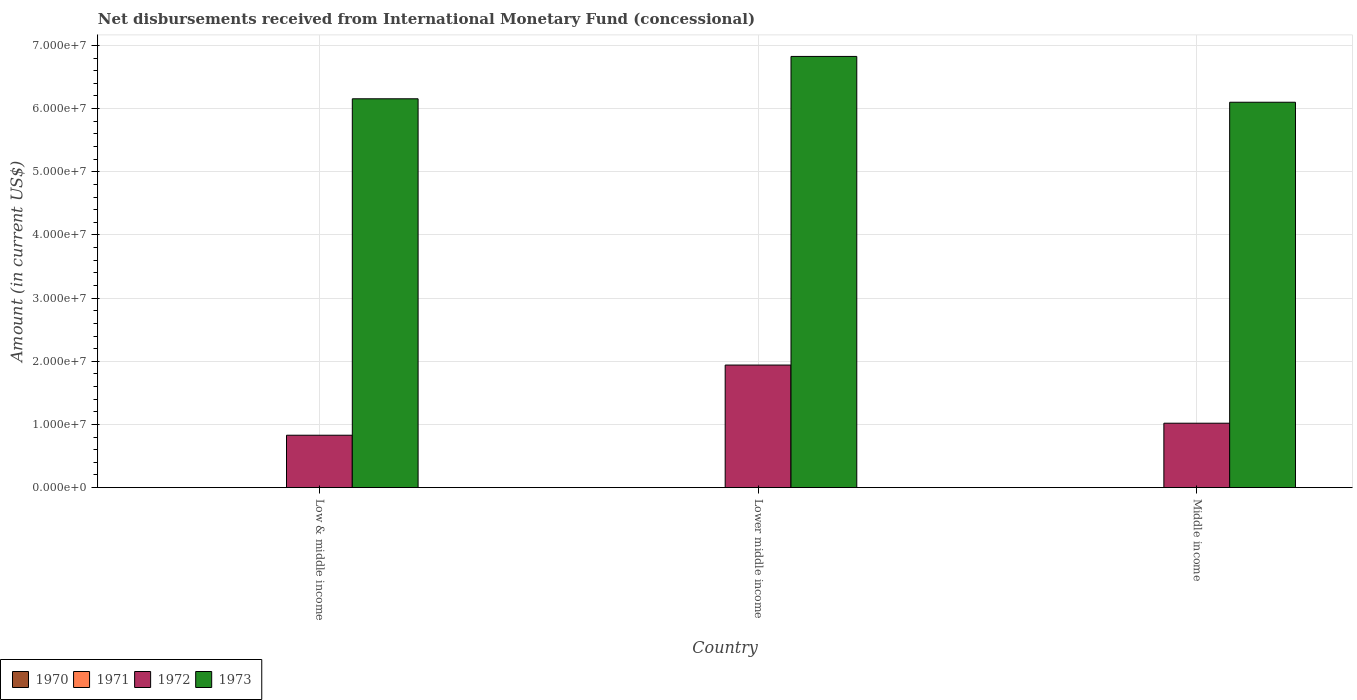How many groups of bars are there?
Provide a short and direct response. 3. Are the number of bars per tick equal to the number of legend labels?
Provide a succinct answer. No. How many bars are there on the 3rd tick from the left?
Your answer should be very brief. 2. What is the label of the 1st group of bars from the left?
Provide a short and direct response. Low & middle income. In how many cases, is the number of bars for a given country not equal to the number of legend labels?
Your answer should be compact. 3. What is the amount of disbursements received from International Monetary Fund in 1971 in Low & middle income?
Ensure brevity in your answer.  0. Across all countries, what is the maximum amount of disbursements received from International Monetary Fund in 1973?
Provide a short and direct response. 6.83e+07. In which country was the amount of disbursements received from International Monetary Fund in 1972 maximum?
Keep it short and to the point. Lower middle income. What is the difference between the amount of disbursements received from International Monetary Fund in 1973 in Low & middle income and that in Lower middle income?
Provide a short and direct response. -6.70e+06. What is the difference between the amount of disbursements received from International Monetary Fund in 1972 in Low & middle income and the amount of disbursements received from International Monetary Fund in 1970 in Lower middle income?
Your response must be concise. 8.30e+06. What is the average amount of disbursements received from International Monetary Fund in 1973 per country?
Give a very brief answer. 6.36e+07. What is the difference between the amount of disbursements received from International Monetary Fund of/in 1972 and amount of disbursements received from International Monetary Fund of/in 1973 in Middle income?
Your response must be concise. -5.08e+07. What is the ratio of the amount of disbursements received from International Monetary Fund in 1972 in Low & middle income to that in Lower middle income?
Ensure brevity in your answer.  0.43. What is the difference between the highest and the second highest amount of disbursements received from International Monetary Fund in 1973?
Your answer should be compact. -7.25e+06. What is the difference between the highest and the lowest amount of disbursements received from International Monetary Fund in 1973?
Provide a succinct answer. 7.25e+06. In how many countries, is the amount of disbursements received from International Monetary Fund in 1973 greater than the average amount of disbursements received from International Monetary Fund in 1973 taken over all countries?
Ensure brevity in your answer.  1. Is the sum of the amount of disbursements received from International Monetary Fund in 1972 in Low & middle income and Middle income greater than the maximum amount of disbursements received from International Monetary Fund in 1970 across all countries?
Provide a succinct answer. Yes. Is it the case that in every country, the sum of the amount of disbursements received from International Monetary Fund in 1970 and amount of disbursements received from International Monetary Fund in 1973 is greater than the sum of amount of disbursements received from International Monetary Fund in 1971 and amount of disbursements received from International Monetary Fund in 1972?
Provide a short and direct response. No. Is it the case that in every country, the sum of the amount of disbursements received from International Monetary Fund in 1971 and amount of disbursements received from International Monetary Fund in 1973 is greater than the amount of disbursements received from International Monetary Fund in 1972?
Your answer should be very brief. Yes. Are all the bars in the graph horizontal?
Provide a succinct answer. No. How many countries are there in the graph?
Your response must be concise. 3. Are the values on the major ticks of Y-axis written in scientific E-notation?
Provide a succinct answer. Yes. Where does the legend appear in the graph?
Provide a succinct answer. Bottom left. How many legend labels are there?
Keep it short and to the point. 4. What is the title of the graph?
Your response must be concise. Net disbursements received from International Monetary Fund (concessional). What is the Amount (in current US$) in 1972 in Low & middle income?
Offer a very short reply. 8.30e+06. What is the Amount (in current US$) in 1973 in Low & middle income?
Keep it short and to the point. 6.16e+07. What is the Amount (in current US$) in 1970 in Lower middle income?
Ensure brevity in your answer.  0. What is the Amount (in current US$) of 1971 in Lower middle income?
Make the answer very short. 0. What is the Amount (in current US$) in 1972 in Lower middle income?
Give a very brief answer. 1.94e+07. What is the Amount (in current US$) in 1973 in Lower middle income?
Keep it short and to the point. 6.83e+07. What is the Amount (in current US$) of 1970 in Middle income?
Provide a succinct answer. 0. What is the Amount (in current US$) in 1971 in Middle income?
Your response must be concise. 0. What is the Amount (in current US$) in 1972 in Middle income?
Make the answer very short. 1.02e+07. What is the Amount (in current US$) of 1973 in Middle income?
Offer a very short reply. 6.10e+07. Across all countries, what is the maximum Amount (in current US$) of 1972?
Keep it short and to the point. 1.94e+07. Across all countries, what is the maximum Amount (in current US$) in 1973?
Give a very brief answer. 6.83e+07. Across all countries, what is the minimum Amount (in current US$) of 1972?
Your answer should be very brief. 8.30e+06. Across all countries, what is the minimum Amount (in current US$) of 1973?
Give a very brief answer. 6.10e+07. What is the total Amount (in current US$) of 1971 in the graph?
Give a very brief answer. 0. What is the total Amount (in current US$) of 1972 in the graph?
Your response must be concise. 3.79e+07. What is the total Amount (in current US$) of 1973 in the graph?
Keep it short and to the point. 1.91e+08. What is the difference between the Amount (in current US$) in 1972 in Low & middle income and that in Lower middle income?
Your answer should be compact. -1.11e+07. What is the difference between the Amount (in current US$) in 1973 in Low & middle income and that in Lower middle income?
Your answer should be very brief. -6.70e+06. What is the difference between the Amount (in current US$) of 1972 in Low & middle income and that in Middle income?
Your response must be concise. -1.90e+06. What is the difference between the Amount (in current US$) in 1973 in Low & middle income and that in Middle income?
Offer a terse response. 5.46e+05. What is the difference between the Amount (in current US$) in 1972 in Lower middle income and that in Middle income?
Your answer should be very brief. 9.21e+06. What is the difference between the Amount (in current US$) in 1973 in Lower middle income and that in Middle income?
Your answer should be compact. 7.25e+06. What is the difference between the Amount (in current US$) of 1972 in Low & middle income and the Amount (in current US$) of 1973 in Lower middle income?
Provide a short and direct response. -6.00e+07. What is the difference between the Amount (in current US$) of 1972 in Low & middle income and the Amount (in current US$) of 1973 in Middle income?
Keep it short and to the point. -5.27e+07. What is the difference between the Amount (in current US$) in 1972 in Lower middle income and the Amount (in current US$) in 1973 in Middle income?
Your answer should be compact. -4.16e+07. What is the average Amount (in current US$) in 1971 per country?
Ensure brevity in your answer.  0. What is the average Amount (in current US$) in 1972 per country?
Your answer should be very brief. 1.26e+07. What is the average Amount (in current US$) of 1973 per country?
Your response must be concise. 6.36e+07. What is the difference between the Amount (in current US$) in 1972 and Amount (in current US$) in 1973 in Low & middle income?
Provide a succinct answer. -5.33e+07. What is the difference between the Amount (in current US$) in 1972 and Amount (in current US$) in 1973 in Lower middle income?
Ensure brevity in your answer.  -4.89e+07. What is the difference between the Amount (in current US$) of 1972 and Amount (in current US$) of 1973 in Middle income?
Offer a terse response. -5.08e+07. What is the ratio of the Amount (in current US$) in 1972 in Low & middle income to that in Lower middle income?
Make the answer very short. 0.43. What is the ratio of the Amount (in current US$) in 1973 in Low & middle income to that in Lower middle income?
Keep it short and to the point. 0.9. What is the ratio of the Amount (in current US$) of 1972 in Low & middle income to that in Middle income?
Offer a terse response. 0.81. What is the ratio of the Amount (in current US$) in 1972 in Lower middle income to that in Middle income?
Your answer should be compact. 1.9. What is the ratio of the Amount (in current US$) of 1973 in Lower middle income to that in Middle income?
Offer a very short reply. 1.12. What is the difference between the highest and the second highest Amount (in current US$) of 1972?
Keep it short and to the point. 9.21e+06. What is the difference between the highest and the second highest Amount (in current US$) of 1973?
Make the answer very short. 6.70e+06. What is the difference between the highest and the lowest Amount (in current US$) of 1972?
Give a very brief answer. 1.11e+07. What is the difference between the highest and the lowest Amount (in current US$) in 1973?
Make the answer very short. 7.25e+06. 